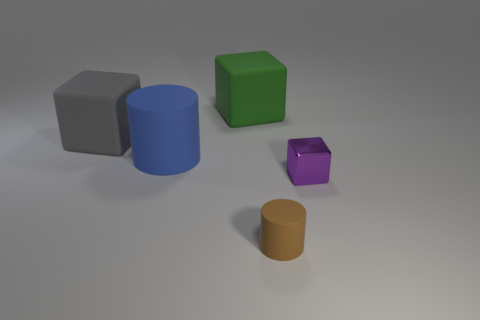What materials do the objects seem to be made of based on their shininess and texture? Based on their shininess and texture, the objects appear to be made of different kinds of smooth plastics or metals. The blue and gray objects have a matte finish, suggesting a less reflective material, possibly plastic. The orange, green, and purple objects have more luster, indicating a potentially smoother or slightly metallic material. 